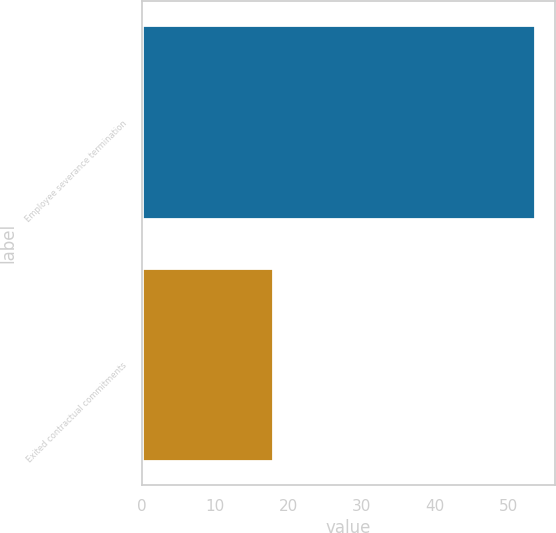<chart> <loc_0><loc_0><loc_500><loc_500><bar_chart><fcel>Employee severance termination<fcel>Exited contractual commitments<nl><fcel>53.6<fcel>17.9<nl></chart> 